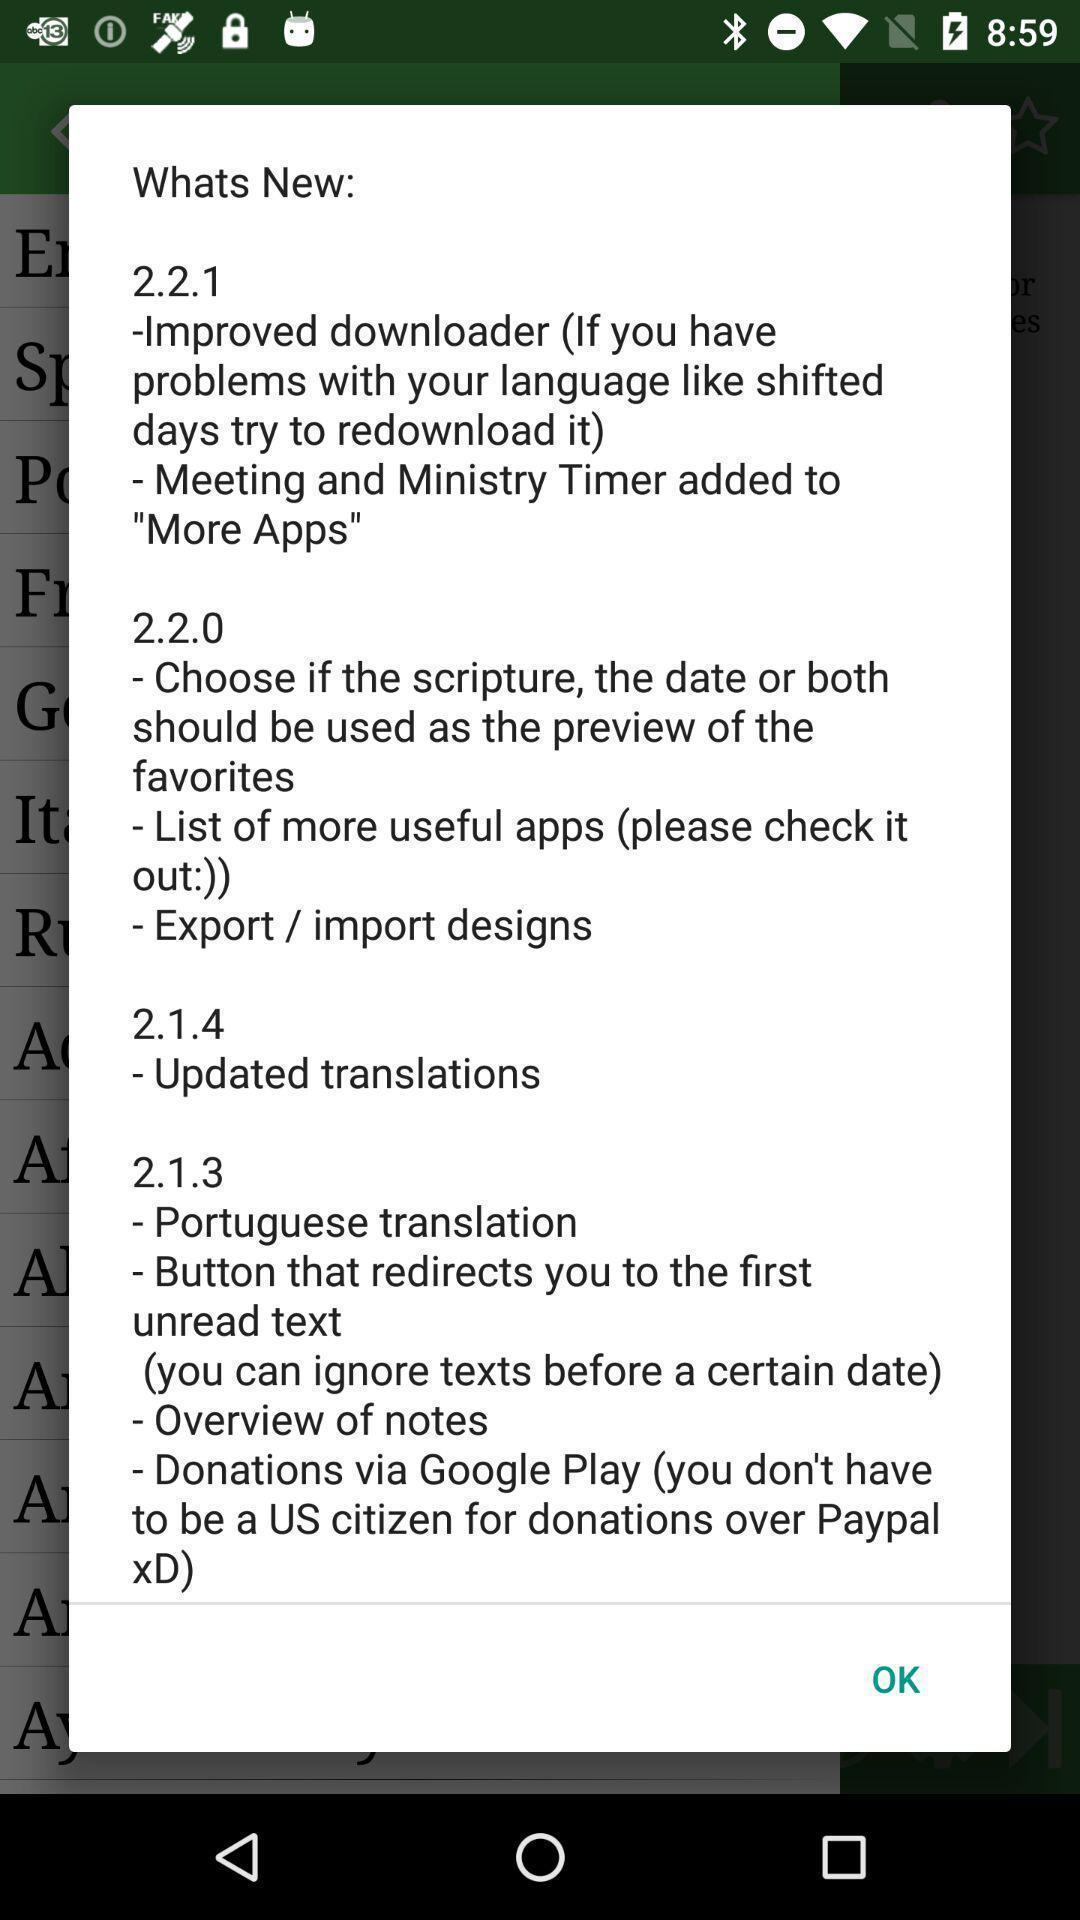What details can you identify in this image? Popup showing versions. 